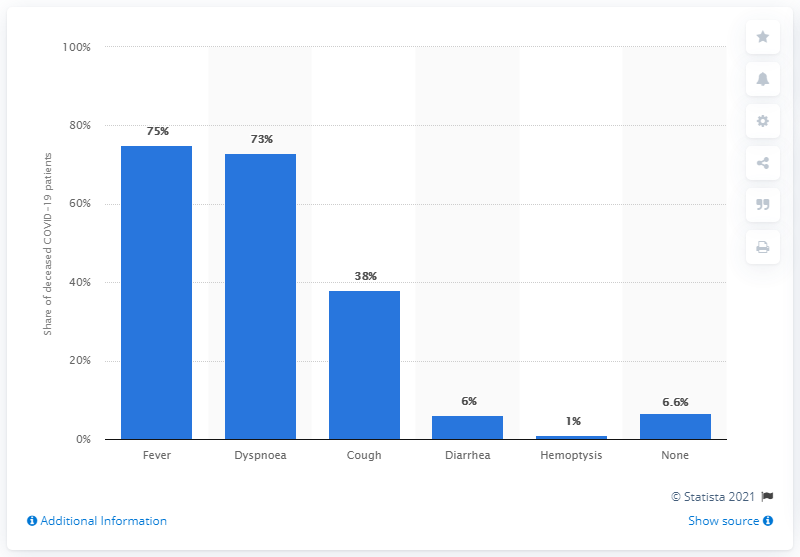Point out several critical features in this image. Out of the individuals who were hospitalized with COVID-19, 38% reported having a cough as a symptom. 